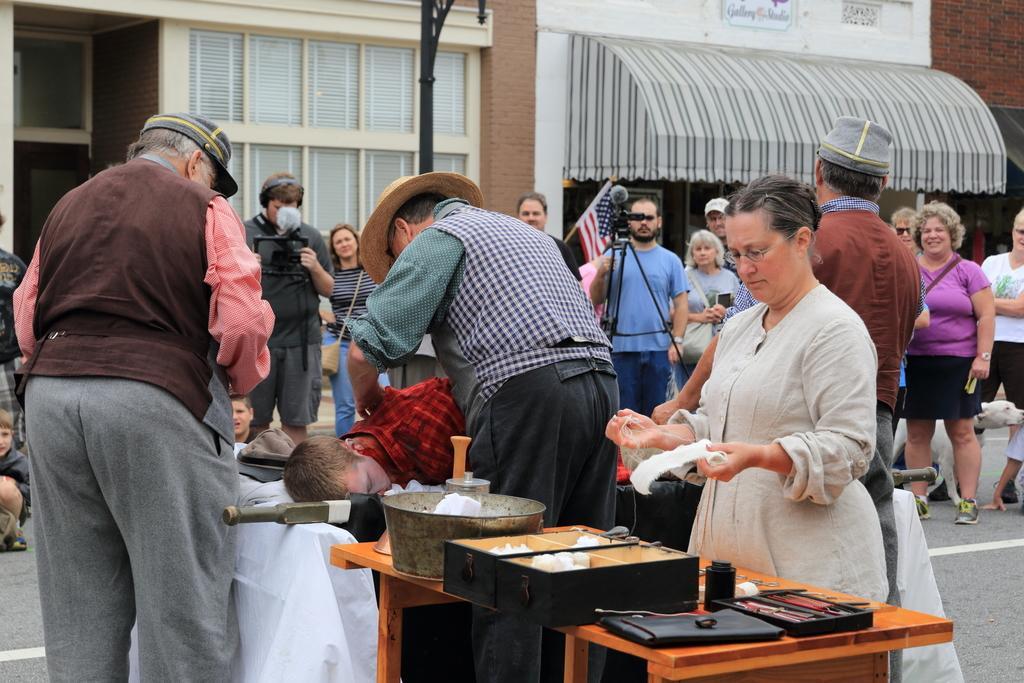Please provide a concise description of this image. There are many people standing. In the front a person wearing brown shirt is wearing a cap. There is a table. On the table there is a box, vessel and some other items. In the background there are building with windows. And a person wearing a blue t shirt is holding a video camera. 